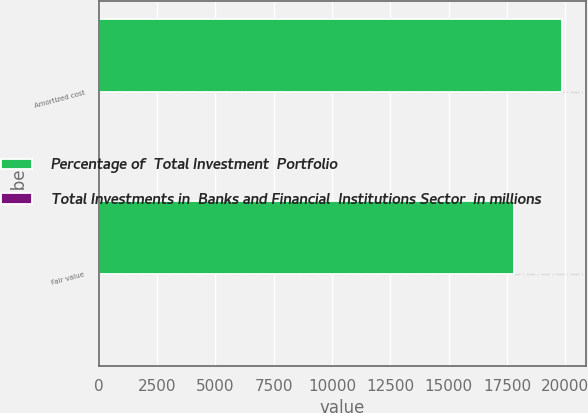<chart> <loc_0><loc_0><loc_500><loc_500><stacked_bar_chart><ecel><fcel>Amortized cost<fcel>Fair value<nl><fcel>Percentage of  Total Investment  Portfolio<fcel>19868<fcel>17793<nl><fcel>Total Investments in  Banks and Financial  Institutions Sector  in millions<fcel>28<fcel>27<nl></chart> 